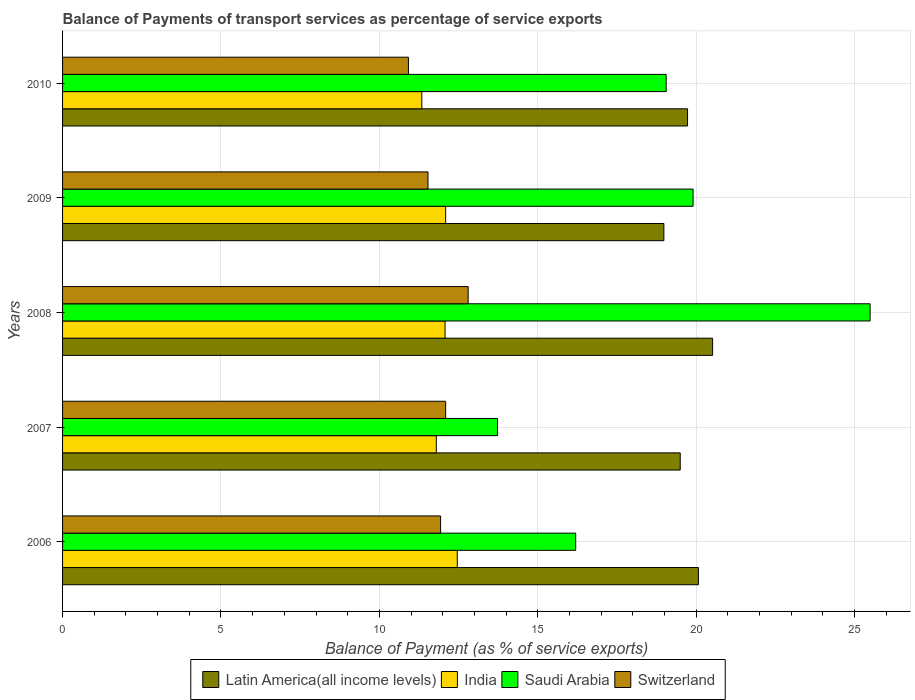How many different coloured bars are there?
Keep it short and to the point. 4. How many groups of bars are there?
Offer a terse response. 5. Are the number of bars per tick equal to the number of legend labels?
Give a very brief answer. Yes. Are the number of bars on each tick of the Y-axis equal?
Your answer should be compact. Yes. How many bars are there on the 3rd tick from the bottom?
Provide a short and direct response. 4. What is the label of the 2nd group of bars from the top?
Offer a very short reply. 2009. What is the balance of payments of transport services in Latin America(all income levels) in 2007?
Provide a short and direct response. 19.5. Across all years, what is the maximum balance of payments of transport services in India?
Your answer should be compact. 12.46. Across all years, what is the minimum balance of payments of transport services in India?
Your answer should be very brief. 11.34. In which year was the balance of payments of transport services in Latin America(all income levels) maximum?
Offer a very short reply. 2008. What is the total balance of payments of transport services in Latin America(all income levels) in the graph?
Your answer should be compact. 98.79. What is the difference between the balance of payments of transport services in Saudi Arabia in 2006 and that in 2010?
Give a very brief answer. -2.86. What is the difference between the balance of payments of transport services in Latin America(all income levels) in 2010 and the balance of payments of transport services in India in 2008?
Your answer should be very brief. 7.65. What is the average balance of payments of transport services in India per year?
Offer a very short reply. 11.95. In the year 2006, what is the difference between the balance of payments of transport services in India and balance of payments of transport services in Saudi Arabia?
Your response must be concise. -3.74. In how many years, is the balance of payments of transport services in Switzerland greater than 18 %?
Your answer should be very brief. 0. What is the ratio of the balance of payments of transport services in Switzerland in 2008 to that in 2009?
Your answer should be very brief. 1.11. Is the difference between the balance of payments of transport services in India in 2006 and 2008 greater than the difference between the balance of payments of transport services in Saudi Arabia in 2006 and 2008?
Your answer should be compact. Yes. What is the difference between the highest and the second highest balance of payments of transport services in India?
Provide a succinct answer. 0.37. What is the difference between the highest and the lowest balance of payments of transport services in Saudi Arabia?
Give a very brief answer. 11.76. Is the sum of the balance of payments of transport services in Switzerland in 2007 and 2008 greater than the maximum balance of payments of transport services in Saudi Arabia across all years?
Your answer should be very brief. No. What does the 1st bar from the top in 2010 represents?
Ensure brevity in your answer.  Switzerland. What does the 4th bar from the bottom in 2009 represents?
Your response must be concise. Switzerland. How many bars are there?
Give a very brief answer. 20. How many years are there in the graph?
Give a very brief answer. 5. Are the values on the major ticks of X-axis written in scientific E-notation?
Give a very brief answer. No. Does the graph contain any zero values?
Offer a very short reply. No. How many legend labels are there?
Give a very brief answer. 4. What is the title of the graph?
Provide a succinct answer. Balance of Payments of transport services as percentage of service exports. Does "Brazil" appear as one of the legend labels in the graph?
Offer a very short reply. No. What is the label or title of the X-axis?
Your answer should be very brief. Balance of Payment (as % of service exports). What is the label or title of the Y-axis?
Your answer should be compact. Years. What is the Balance of Payment (as % of service exports) of Latin America(all income levels) in 2006?
Your answer should be very brief. 20.07. What is the Balance of Payment (as % of service exports) in India in 2006?
Your answer should be very brief. 12.46. What is the Balance of Payment (as % of service exports) of Saudi Arabia in 2006?
Keep it short and to the point. 16.2. What is the Balance of Payment (as % of service exports) in Switzerland in 2006?
Your answer should be compact. 11.93. What is the Balance of Payment (as % of service exports) of Latin America(all income levels) in 2007?
Your answer should be very brief. 19.5. What is the Balance of Payment (as % of service exports) in India in 2007?
Offer a very short reply. 11.8. What is the Balance of Payment (as % of service exports) of Saudi Arabia in 2007?
Give a very brief answer. 13.73. What is the Balance of Payment (as % of service exports) in Switzerland in 2007?
Ensure brevity in your answer.  12.09. What is the Balance of Payment (as % of service exports) of Latin America(all income levels) in 2008?
Offer a terse response. 20.52. What is the Balance of Payment (as % of service exports) of India in 2008?
Your answer should be very brief. 12.07. What is the Balance of Payment (as % of service exports) of Saudi Arabia in 2008?
Offer a very short reply. 25.49. What is the Balance of Payment (as % of service exports) in Switzerland in 2008?
Your answer should be very brief. 12.8. What is the Balance of Payment (as % of service exports) of Latin America(all income levels) in 2009?
Make the answer very short. 18.98. What is the Balance of Payment (as % of service exports) in India in 2009?
Your response must be concise. 12.09. What is the Balance of Payment (as % of service exports) of Saudi Arabia in 2009?
Offer a terse response. 19.9. What is the Balance of Payment (as % of service exports) in Switzerland in 2009?
Ensure brevity in your answer.  11.54. What is the Balance of Payment (as % of service exports) in Latin America(all income levels) in 2010?
Provide a short and direct response. 19.73. What is the Balance of Payment (as % of service exports) of India in 2010?
Ensure brevity in your answer.  11.34. What is the Balance of Payment (as % of service exports) of Saudi Arabia in 2010?
Offer a terse response. 19.05. What is the Balance of Payment (as % of service exports) of Switzerland in 2010?
Provide a short and direct response. 10.92. Across all years, what is the maximum Balance of Payment (as % of service exports) in Latin America(all income levels)?
Keep it short and to the point. 20.52. Across all years, what is the maximum Balance of Payment (as % of service exports) of India?
Your answer should be compact. 12.46. Across all years, what is the maximum Balance of Payment (as % of service exports) in Saudi Arabia?
Make the answer very short. 25.49. Across all years, what is the maximum Balance of Payment (as % of service exports) of Switzerland?
Your response must be concise. 12.8. Across all years, what is the minimum Balance of Payment (as % of service exports) of Latin America(all income levels)?
Give a very brief answer. 18.98. Across all years, what is the minimum Balance of Payment (as % of service exports) of India?
Keep it short and to the point. 11.34. Across all years, what is the minimum Balance of Payment (as % of service exports) of Saudi Arabia?
Keep it short and to the point. 13.73. Across all years, what is the minimum Balance of Payment (as % of service exports) in Switzerland?
Offer a terse response. 10.92. What is the total Balance of Payment (as % of service exports) in Latin America(all income levels) in the graph?
Offer a very short reply. 98.79. What is the total Balance of Payment (as % of service exports) of India in the graph?
Offer a very short reply. 59.76. What is the total Balance of Payment (as % of service exports) of Saudi Arabia in the graph?
Offer a terse response. 94.37. What is the total Balance of Payment (as % of service exports) in Switzerland in the graph?
Provide a short and direct response. 59.28. What is the difference between the Balance of Payment (as % of service exports) of Latin America(all income levels) in 2006 and that in 2007?
Offer a terse response. 0.57. What is the difference between the Balance of Payment (as % of service exports) in India in 2006 and that in 2007?
Provide a succinct answer. 0.66. What is the difference between the Balance of Payment (as % of service exports) of Saudi Arabia in 2006 and that in 2007?
Provide a succinct answer. 2.47. What is the difference between the Balance of Payment (as % of service exports) of Switzerland in 2006 and that in 2007?
Give a very brief answer. -0.16. What is the difference between the Balance of Payment (as % of service exports) of Latin America(all income levels) in 2006 and that in 2008?
Provide a succinct answer. -0.45. What is the difference between the Balance of Payment (as % of service exports) in India in 2006 and that in 2008?
Your answer should be very brief. 0.39. What is the difference between the Balance of Payment (as % of service exports) in Saudi Arabia in 2006 and that in 2008?
Keep it short and to the point. -9.29. What is the difference between the Balance of Payment (as % of service exports) of Switzerland in 2006 and that in 2008?
Ensure brevity in your answer.  -0.87. What is the difference between the Balance of Payment (as % of service exports) of Latin America(all income levels) in 2006 and that in 2009?
Ensure brevity in your answer.  1.09. What is the difference between the Balance of Payment (as % of service exports) in India in 2006 and that in 2009?
Your answer should be compact. 0.37. What is the difference between the Balance of Payment (as % of service exports) in Saudi Arabia in 2006 and that in 2009?
Your answer should be very brief. -3.71. What is the difference between the Balance of Payment (as % of service exports) of Switzerland in 2006 and that in 2009?
Your response must be concise. 0.4. What is the difference between the Balance of Payment (as % of service exports) in Latin America(all income levels) in 2006 and that in 2010?
Keep it short and to the point. 0.34. What is the difference between the Balance of Payment (as % of service exports) of India in 2006 and that in 2010?
Your response must be concise. 1.12. What is the difference between the Balance of Payment (as % of service exports) in Saudi Arabia in 2006 and that in 2010?
Make the answer very short. -2.86. What is the difference between the Balance of Payment (as % of service exports) in Switzerland in 2006 and that in 2010?
Offer a terse response. 1.01. What is the difference between the Balance of Payment (as % of service exports) in Latin America(all income levels) in 2007 and that in 2008?
Your answer should be very brief. -1.02. What is the difference between the Balance of Payment (as % of service exports) of India in 2007 and that in 2008?
Provide a succinct answer. -0.28. What is the difference between the Balance of Payment (as % of service exports) in Saudi Arabia in 2007 and that in 2008?
Offer a terse response. -11.76. What is the difference between the Balance of Payment (as % of service exports) in Switzerland in 2007 and that in 2008?
Provide a short and direct response. -0.71. What is the difference between the Balance of Payment (as % of service exports) in Latin America(all income levels) in 2007 and that in 2009?
Offer a terse response. 0.52. What is the difference between the Balance of Payment (as % of service exports) of India in 2007 and that in 2009?
Provide a short and direct response. -0.3. What is the difference between the Balance of Payment (as % of service exports) in Saudi Arabia in 2007 and that in 2009?
Your answer should be compact. -6.17. What is the difference between the Balance of Payment (as % of service exports) of Switzerland in 2007 and that in 2009?
Your answer should be very brief. 0.56. What is the difference between the Balance of Payment (as % of service exports) in Latin America(all income levels) in 2007 and that in 2010?
Offer a very short reply. -0.23. What is the difference between the Balance of Payment (as % of service exports) of India in 2007 and that in 2010?
Ensure brevity in your answer.  0.46. What is the difference between the Balance of Payment (as % of service exports) in Saudi Arabia in 2007 and that in 2010?
Give a very brief answer. -5.33. What is the difference between the Balance of Payment (as % of service exports) of Switzerland in 2007 and that in 2010?
Keep it short and to the point. 1.17. What is the difference between the Balance of Payment (as % of service exports) in Latin America(all income levels) in 2008 and that in 2009?
Your response must be concise. 1.54. What is the difference between the Balance of Payment (as % of service exports) in India in 2008 and that in 2009?
Keep it short and to the point. -0.02. What is the difference between the Balance of Payment (as % of service exports) in Saudi Arabia in 2008 and that in 2009?
Provide a succinct answer. 5.59. What is the difference between the Balance of Payment (as % of service exports) of Switzerland in 2008 and that in 2009?
Make the answer very short. 1.27. What is the difference between the Balance of Payment (as % of service exports) in Latin America(all income levels) in 2008 and that in 2010?
Your response must be concise. 0.79. What is the difference between the Balance of Payment (as % of service exports) in India in 2008 and that in 2010?
Keep it short and to the point. 0.73. What is the difference between the Balance of Payment (as % of service exports) in Saudi Arabia in 2008 and that in 2010?
Offer a very short reply. 6.44. What is the difference between the Balance of Payment (as % of service exports) of Switzerland in 2008 and that in 2010?
Make the answer very short. 1.89. What is the difference between the Balance of Payment (as % of service exports) in Latin America(all income levels) in 2009 and that in 2010?
Provide a short and direct response. -0.75. What is the difference between the Balance of Payment (as % of service exports) of India in 2009 and that in 2010?
Provide a short and direct response. 0.75. What is the difference between the Balance of Payment (as % of service exports) in Saudi Arabia in 2009 and that in 2010?
Provide a succinct answer. 0.85. What is the difference between the Balance of Payment (as % of service exports) of Switzerland in 2009 and that in 2010?
Give a very brief answer. 0.62. What is the difference between the Balance of Payment (as % of service exports) of Latin America(all income levels) in 2006 and the Balance of Payment (as % of service exports) of India in 2007?
Ensure brevity in your answer.  8.27. What is the difference between the Balance of Payment (as % of service exports) in Latin America(all income levels) in 2006 and the Balance of Payment (as % of service exports) in Saudi Arabia in 2007?
Ensure brevity in your answer.  6.34. What is the difference between the Balance of Payment (as % of service exports) of Latin America(all income levels) in 2006 and the Balance of Payment (as % of service exports) of Switzerland in 2007?
Give a very brief answer. 7.98. What is the difference between the Balance of Payment (as % of service exports) of India in 2006 and the Balance of Payment (as % of service exports) of Saudi Arabia in 2007?
Make the answer very short. -1.27. What is the difference between the Balance of Payment (as % of service exports) of India in 2006 and the Balance of Payment (as % of service exports) of Switzerland in 2007?
Provide a succinct answer. 0.37. What is the difference between the Balance of Payment (as % of service exports) in Saudi Arabia in 2006 and the Balance of Payment (as % of service exports) in Switzerland in 2007?
Your response must be concise. 4.1. What is the difference between the Balance of Payment (as % of service exports) of Latin America(all income levels) in 2006 and the Balance of Payment (as % of service exports) of India in 2008?
Keep it short and to the point. 8. What is the difference between the Balance of Payment (as % of service exports) in Latin America(all income levels) in 2006 and the Balance of Payment (as % of service exports) in Saudi Arabia in 2008?
Your answer should be compact. -5.42. What is the difference between the Balance of Payment (as % of service exports) in Latin America(all income levels) in 2006 and the Balance of Payment (as % of service exports) in Switzerland in 2008?
Provide a succinct answer. 7.27. What is the difference between the Balance of Payment (as % of service exports) in India in 2006 and the Balance of Payment (as % of service exports) in Saudi Arabia in 2008?
Give a very brief answer. -13.03. What is the difference between the Balance of Payment (as % of service exports) of India in 2006 and the Balance of Payment (as % of service exports) of Switzerland in 2008?
Your answer should be very brief. -0.34. What is the difference between the Balance of Payment (as % of service exports) in Saudi Arabia in 2006 and the Balance of Payment (as % of service exports) in Switzerland in 2008?
Your response must be concise. 3.39. What is the difference between the Balance of Payment (as % of service exports) in Latin America(all income levels) in 2006 and the Balance of Payment (as % of service exports) in India in 2009?
Offer a very short reply. 7.98. What is the difference between the Balance of Payment (as % of service exports) of Latin America(all income levels) in 2006 and the Balance of Payment (as % of service exports) of Saudi Arabia in 2009?
Ensure brevity in your answer.  0.17. What is the difference between the Balance of Payment (as % of service exports) in Latin America(all income levels) in 2006 and the Balance of Payment (as % of service exports) in Switzerland in 2009?
Keep it short and to the point. 8.54. What is the difference between the Balance of Payment (as % of service exports) in India in 2006 and the Balance of Payment (as % of service exports) in Saudi Arabia in 2009?
Keep it short and to the point. -7.44. What is the difference between the Balance of Payment (as % of service exports) of India in 2006 and the Balance of Payment (as % of service exports) of Switzerland in 2009?
Your answer should be compact. 0.92. What is the difference between the Balance of Payment (as % of service exports) in Saudi Arabia in 2006 and the Balance of Payment (as % of service exports) in Switzerland in 2009?
Make the answer very short. 4.66. What is the difference between the Balance of Payment (as % of service exports) of Latin America(all income levels) in 2006 and the Balance of Payment (as % of service exports) of India in 2010?
Your response must be concise. 8.73. What is the difference between the Balance of Payment (as % of service exports) of Latin America(all income levels) in 2006 and the Balance of Payment (as % of service exports) of Saudi Arabia in 2010?
Make the answer very short. 1.02. What is the difference between the Balance of Payment (as % of service exports) in Latin America(all income levels) in 2006 and the Balance of Payment (as % of service exports) in Switzerland in 2010?
Ensure brevity in your answer.  9.15. What is the difference between the Balance of Payment (as % of service exports) in India in 2006 and the Balance of Payment (as % of service exports) in Saudi Arabia in 2010?
Offer a very short reply. -6.59. What is the difference between the Balance of Payment (as % of service exports) of India in 2006 and the Balance of Payment (as % of service exports) of Switzerland in 2010?
Provide a short and direct response. 1.54. What is the difference between the Balance of Payment (as % of service exports) in Saudi Arabia in 2006 and the Balance of Payment (as % of service exports) in Switzerland in 2010?
Make the answer very short. 5.28. What is the difference between the Balance of Payment (as % of service exports) in Latin America(all income levels) in 2007 and the Balance of Payment (as % of service exports) in India in 2008?
Keep it short and to the point. 7.42. What is the difference between the Balance of Payment (as % of service exports) of Latin America(all income levels) in 2007 and the Balance of Payment (as % of service exports) of Saudi Arabia in 2008?
Give a very brief answer. -5.99. What is the difference between the Balance of Payment (as % of service exports) in Latin America(all income levels) in 2007 and the Balance of Payment (as % of service exports) in Switzerland in 2008?
Ensure brevity in your answer.  6.69. What is the difference between the Balance of Payment (as % of service exports) of India in 2007 and the Balance of Payment (as % of service exports) of Saudi Arabia in 2008?
Give a very brief answer. -13.69. What is the difference between the Balance of Payment (as % of service exports) of India in 2007 and the Balance of Payment (as % of service exports) of Switzerland in 2008?
Offer a very short reply. -1.01. What is the difference between the Balance of Payment (as % of service exports) of Saudi Arabia in 2007 and the Balance of Payment (as % of service exports) of Switzerland in 2008?
Give a very brief answer. 0.93. What is the difference between the Balance of Payment (as % of service exports) of Latin America(all income levels) in 2007 and the Balance of Payment (as % of service exports) of India in 2009?
Give a very brief answer. 7.4. What is the difference between the Balance of Payment (as % of service exports) of Latin America(all income levels) in 2007 and the Balance of Payment (as % of service exports) of Saudi Arabia in 2009?
Your answer should be compact. -0.41. What is the difference between the Balance of Payment (as % of service exports) in Latin America(all income levels) in 2007 and the Balance of Payment (as % of service exports) in Switzerland in 2009?
Your answer should be compact. 7.96. What is the difference between the Balance of Payment (as % of service exports) in India in 2007 and the Balance of Payment (as % of service exports) in Saudi Arabia in 2009?
Offer a very short reply. -8.11. What is the difference between the Balance of Payment (as % of service exports) in India in 2007 and the Balance of Payment (as % of service exports) in Switzerland in 2009?
Provide a succinct answer. 0.26. What is the difference between the Balance of Payment (as % of service exports) of Saudi Arabia in 2007 and the Balance of Payment (as % of service exports) of Switzerland in 2009?
Your answer should be very brief. 2.19. What is the difference between the Balance of Payment (as % of service exports) of Latin America(all income levels) in 2007 and the Balance of Payment (as % of service exports) of India in 2010?
Ensure brevity in your answer.  8.16. What is the difference between the Balance of Payment (as % of service exports) of Latin America(all income levels) in 2007 and the Balance of Payment (as % of service exports) of Saudi Arabia in 2010?
Provide a short and direct response. 0.44. What is the difference between the Balance of Payment (as % of service exports) in Latin America(all income levels) in 2007 and the Balance of Payment (as % of service exports) in Switzerland in 2010?
Offer a very short reply. 8.58. What is the difference between the Balance of Payment (as % of service exports) in India in 2007 and the Balance of Payment (as % of service exports) in Saudi Arabia in 2010?
Offer a terse response. -7.26. What is the difference between the Balance of Payment (as % of service exports) in India in 2007 and the Balance of Payment (as % of service exports) in Switzerland in 2010?
Keep it short and to the point. 0.88. What is the difference between the Balance of Payment (as % of service exports) of Saudi Arabia in 2007 and the Balance of Payment (as % of service exports) of Switzerland in 2010?
Your answer should be compact. 2.81. What is the difference between the Balance of Payment (as % of service exports) in Latin America(all income levels) in 2008 and the Balance of Payment (as % of service exports) in India in 2009?
Offer a terse response. 8.43. What is the difference between the Balance of Payment (as % of service exports) of Latin America(all income levels) in 2008 and the Balance of Payment (as % of service exports) of Saudi Arabia in 2009?
Your response must be concise. 0.62. What is the difference between the Balance of Payment (as % of service exports) of Latin America(all income levels) in 2008 and the Balance of Payment (as % of service exports) of Switzerland in 2009?
Offer a very short reply. 8.98. What is the difference between the Balance of Payment (as % of service exports) in India in 2008 and the Balance of Payment (as % of service exports) in Saudi Arabia in 2009?
Ensure brevity in your answer.  -7.83. What is the difference between the Balance of Payment (as % of service exports) in India in 2008 and the Balance of Payment (as % of service exports) in Switzerland in 2009?
Give a very brief answer. 0.54. What is the difference between the Balance of Payment (as % of service exports) of Saudi Arabia in 2008 and the Balance of Payment (as % of service exports) of Switzerland in 2009?
Ensure brevity in your answer.  13.96. What is the difference between the Balance of Payment (as % of service exports) of Latin America(all income levels) in 2008 and the Balance of Payment (as % of service exports) of India in 2010?
Provide a short and direct response. 9.18. What is the difference between the Balance of Payment (as % of service exports) in Latin America(all income levels) in 2008 and the Balance of Payment (as % of service exports) in Saudi Arabia in 2010?
Ensure brevity in your answer.  1.47. What is the difference between the Balance of Payment (as % of service exports) in Latin America(all income levels) in 2008 and the Balance of Payment (as % of service exports) in Switzerland in 2010?
Your answer should be compact. 9.6. What is the difference between the Balance of Payment (as % of service exports) of India in 2008 and the Balance of Payment (as % of service exports) of Saudi Arabia in 2010?
Offer a very short reply. -6.98. What is the difference between the Balance of Payment (as % of service exports) of India in 2008 and the Balance of Payment (as % of service exports) of Switzerland in 2010?
Keep it short and to the point. 1.16. What is the difference between the Balance of Payment (as % of service exports) of Saudi Arabia in 2008 and the Balance of Payment (as % of service exports) of Switzerland in 2010?
Ensure brevity in your answer.  14.57. What is the difference between the Balance of Payment (as % of service exports) of Latin America(all income levels) in 2009 and the Balance of Payment (as % of service exports) of India in 2010?
Offer a very short reply. 7.64. What is the difference between the Balance of Payment (as % of service exports) in Latin America(all income levels) in 2009 and the Balance of Payment (as % of service exports) in Saudi Arabia in 2010?
Your answer should be compact. -0.07. What is the difference between the Balance of Payment (as % of service exports) of Latin America(all income levels) in 2009 and the Balance of Payment (as % of service exports) of Switzerland in 2010?
Provide a short and direct response. 8.06. What is the difference between the Balance of Payment (as % of service exports) in India in 2009 and the Balance of Payment (as % of service exports) in Saudi Arabia in 2010?
Offer a very short reply. -6.96. What is the difference between the Balance of Payment (as % of service exports) in India in 2009 and the Balance of Payment (as % of service exports) in Switzerland in 2010?
Ensure brevity in your answer.  1.18. What is the difference between the Balance of Payment (as % of service exports) of Saudi Arabia in 2009 and the Balance of Payment (as % of service exports) of Switzerland in 2010?
Provide a short and direct response. 8.98. What is the average Balance of Payment (as % of service exports) in Latin America(all income levels) per year?
Give a very brief answer. 19.76. What is the average Balance of Payment (as % of service exports) of India per year?
Your response must be concise. 11.95. What is the average Balance of Payment (as % of service exports) in Saudi Arabia per year?
Offer a terse response. 18.87. What is the average Balance of Payment (as % of service exports) of Switzerland per year?
Provide a short and direct response. 11.86. In the year 2006, what is the difference between the Balance of Payment (as % of service exports) of Latin America(all income levels) and Balance of Payment (as % of service exports) of India?
Give a very brief answer. 7.61. In the year 2006, what is the difference between the Balance of Payment (as % of service exports) of Latin America(all income levels) and Balance of Payment (as % of service exports) of Saudi Arabia?
Make the answer very short. 3.87. In the year 2006, what is the difference between the Balance of Payment (as % of service exports) in Latin America(all income levels) and Balance of Payment (as % of service exports) in Switzerland?
Provide a succinct answer. 8.14. In the year 2006, what is the difference between the Balance of Payment (as % of service exports) of India and Balance of Payment (as % of service exports) of Saudi Arabia?
Give a very brief answer. -3.74. In the year 2006, what is the difference between the Balance of Payment (as % of service exports) of India and Balance of Payment (as % of service exports) of Switzerland?
Make the answer very short. 0.53. In the year 2006, what is the difference between the Balance of Payment (as % of service exports) in Saudi Arabia and Balance of Payment (as % of service exports) in Switzerland?
Offer a terse response. 4.26. In the year 2007, what is the difference between the Balance of Payment (as % of service exports) in Latin America(all income levels) and Balance of Payment (as % of service exports) in India?
Make the answer very short. 7.7. In the year 2007, what is the difference between the Balance of Payment (as % of service exports) of Latin America(all income levels) and Balance of Payment (as % of service exports) of Saudi Arabia?
Offer a terse response. 5.77. In the year 2007, what is the difference between the Balance of Payment (as % of service exports) of Latin America(all income levels) and Balance of Payment (as % of service exports) of Switzerland?
Offer a terse response. 7.4. In the year 2007, what is the difference between the Balance of Payment (as % of service exports) of India and Balance of Payment (as % of service exports) of Saudi Arabia?
Offer a very short reply. -1.93. In the year 2007, what is the difference between the Balance of Payment (as % of service exports) in India and Balance of Payment (as % of service exports) in Switzerland?
Offer a terse response. -0.29. In the year 2007, what is the difference between the Balance of Payment (as % of service exports) of Saudi Arabia and Balance of Payment (as % of service exports) of Switzerland?
Provide a short and direct response. 1.64. In the year 2008, what is the difference between the Balance of Payment (as % of service exports) of Latin America(all income levels) and Balance of Payment (as % of service exports) of India?
Your answer should be compact. 8.45. In the year 2008, what is the difference between the Balance of Payment (as % of service exports) in Latin America(all income levels) and Balance of Payment (as % of service exports) in Saudi Arabia?
Provide a succinct answer. -4.97. In the year 2008, what is the difference between the Balance of Payment (as % of service exports) of Latin America(all income levels) and Balance of Payment (as % of service exports) of Switzerland?
Keep it short and to the point. 7.72. In the year 2008, what is the difference between the Balance of Payment (as % of service exports) in India and Balance of Payment (as % of service exports) in Saudi Arabia?
Offer a very short reply. -13.42. In the year 2008, what is the difference between the Balance of Payment (as % of service exports) of India and Balance of Payment (as % of service exports) of Switzerland?
Make the answer very short. -0.73. In the year 2008, what is the difference between the Balance of Payment (as % of service exports) of Saudi Arabia and Balance of Payment (as % of service exports) of Switzerland?
Offer a very short reply. 12.69. In the year 2009, what is the difference between the Balance of Payment (as % of service exports) in Latin America(all income levels) and Balance of Payment (as % of service exports) in India?
Keep it short and to the point. 6.89. In the year 2009, what is the difference between the Balance of Payment (as % of service exports) in Latin America(all income levels) and Balance of Payment (as % of service exports) in Saudi Arabia?
Give a very brief answer. -0.92. In the year 2009, what is the difference between the Balance of Payment (as % of service exports) in Latin America(all income levels) and Balance of Payment (as % of service exports) in Switzerland?
Provide a short and direct response. 7.45. In the year 2009, what is the difference between the Balance of Payment (as % of service exports) of India and Balance of Payment (as % of service exports) of Saudi Arabia?
Your answer should be compact. -7.81. In the year 2009, what is the difference between the Balance of Payment (as % of service exports) in India and Balance of Payment (as % of service exports) in Switzerland?
Your answer should be very brief. 0.56. In the year 2009, what is the difference between the Balance of Payment (as % of service exports) of Saudi Arabia and Balance of Payment (as % of service exports) of Switzerland?
Your answer should be very brief. 8.37. In the year 2010, what is the difference between the Balance of Payment (as % of service exports) of Latin America(all income levels) and Balance of Payment (as % of service exports) of India?
Keep it short and to the point. 8.39. In the year 2010, what is the difference between the Balance of Payment (as % of service exports) of Latin America(all income levels) and Balance of Payment (as % of service exports) of Saudi Arabia?
Offer a very short reply. 0.67. In the year 2010, what is the difference between the Balance of Payment (as % of service exports) of Latin America(all income levels) and Balance of Payment (as % of service exports) of Switzerland?
Your answer should be very brief. 8.81. In the year 2010, what is the difference between the Balance of Payment (as % of service exports) of India and Balance of Payment (as % of service exports) of Saudi Arabia?
Give a very brief answer. -7.71. In the year 2010, what is the difference between the Balance of Payment (as % of service exports) of India and Balance of Payment (as % of service exports) of Switzerland?
Offer a terse response. 0.42. In the year 2010, what is the difference between the Balance of Payment (as % of service exports) of Saudi Arabia and Balance of Payment (as % of service exports) of Switzerland?
Your answer should be very brief. 8.14. What is the ratio of the Balance of Payment (as % of service exports) in Latin America(all income levels) in 2006 to that in 2007?
Provide a succinct answer. 1.03. What is the ratio of the Balance of Payment (as % of service exports) in India in 2006 to that in 2007?
Offer a terse response. 1.06. What is the ratio of the Balance of Payment (as % of service exports) in Saudi Arabia in 2006 to that in 2007?
Make the answer very short. 1.18. What is the ratio of the Balance of Payment (as % of service exports) of Latin America(all income levels) in 2006 to that in 2008?
Offer a very short reply. 0.98. What is the ratio of the Balance of Payment (as % of service exports) in India in 2006 to that in 2008?
Your answer should be very brief. 1.03. What is the ratio of the Balance of Payment (as % of service exports) in Saudi Arabia in 2006 to that in 2008?
Make the answer very short. 0.64. What is the ratio of the Balance of Payment (as % of service exports) in Switzerland in 2006 to that in 2008?
Ensure brevity in your answer.  0.93. What is the ratio of the Balance of Payment (as % of service exports) in Latin America(all income levels) in 2006 to that in 2009?
Make the answer very short. 1.06. What is the ratio of the Balance of Payment (as % of service exports) in India in 2006 to that in 2009?
Provide a short and direct response. 1.03. What is the ratio of the Balance of Payment (as % of service exports) of Saudi Arabia in 2006 to that in 2009?
Ensure brevity in your answer.  0.81. What is the ratio of the Balance of Payment (as % of service exports) in Switzerland in 2006 to that in 2009?
Offer a terse response. 1.03. What is the ratio of the Balance of Payment (as % of service exports) in Latin America(all income levels) in 2006 to that in 2010?
Provide a succinct answer. 1.02. What is the ratio of the Balance of Payment (as % of service exports) in India in 2006 to that in 2010?
Your response must be concise. 1.1. What is the ratio of the Balance of Payment (as % of service exports) of Saudi Arabia in 2006 to that in 2010?
Your answer should be very brief. 0.85. What is the ratio of the Balance of Payment (as % of service exports) of Switzerland in 2006 to that in 2010?
Offer a terse response. 1.09. What is the ratio of the Balance of Payment (as % of service exports) in Latin America(all income levels) in 2007 to that in 2008?
Ensure brevity in your answer.  0.95. What is the ratio of the Balance of Payment (as % of service exports) in India in 2007 to that in 2008?
Your answer should be very brief. 0.98. What is the ratio of the Balance of Payment (as % of service exports) of Saudi Arabia in 2007 to that in 2008?
Your answer should be compact. 0.54. What is the ratio of the Balance of Payment (as % of service exports) in Switzerland in 2007 to that in 2008?
Give a very brief answer. 0.94. What is the ratio of the Balance of Payment (as % of service exports) of Latin America(all income levels) in 2007 to that in 2009?
Offer a terse response. 1.03. What is the ratio of the Balance of Payment (as % of service exports) of India in 2007 to that in 2009?
Offer a very short reply. 0.98. What is the ratio of the Balance of Payment (as % of service exports) in Saudi Arabia in 2007 to that in 2009?
Provide a short and direct response. 0.69. What is the ratio of the Balance of Payment (as % of service exports) in Switzerland in 2007 to that in 2009?
Give a very brief answer. 1.05. What is the ratio of the Balance of Payment (as % of service exports) in Latin America(all income levels) in 2007 to that in 2010?
Offer a very short reply. 0.99. What is the ratio of the Balance of Payment (as % of service exports) in India in 2007 to that in 2010?
Offer a very short reply. 1.04. What is the ratio of the Balance of Payment (as % of service exports) in Saudi Arabia in 2007 to that in 2010?
Offer a very short reply. 0.72. What is the ratio of the Balance of Payment (as % of service exports) in Switzerland in 2007 to that in 2010?
Provide a succinct answer. 1.11. What is the ratio of the Balance of Payment (as % of service exports) in Latin America(all income levels) in 2008 to that in 2009?
Offer a very short reply. 1.08. What is the ratio of the Balance of Payment (as % of service exports) of Saudi Arabia in 2008 to that in 2009?
Your answer should be very brief. 1.28. What is the ratio of the Balance of Payment (as % of service exports) of Switzerland in 2008 to that in 2009?
Your response must be concise. 1.11. What is the ratio of the Balance of Payment (as % of service exports) of Latin America(all income levels) in 2008 to that in 2010?
Provide a succinct answer. 1.04. What is the ratio of the Balance of Payment (as % of service exports) of India in 2008 to that in 2010?
Ensure brevity in your answer.  1.06. What is the ratio of the Balance of Payment (as % of service exports) of Saudi Arabia in 2008 to that in 2010?
Your answer should be compact. 1.34. What is the ratio of the Balance of Payment (as % of service exports) in Switzerland in 2008 to that in 2010?
Give a very brief answer. 1.17. What is the ratio of the Balance of Payment (as % of service exports) of Latin America(all income levels) in 2009 to that in 2010?
Your answer should be very brief. 0.96. What is the ratio of the Balance of Payment (as % of service exports) of India in 2009 to that in 2010?
Your response must be concise. 1.07. What is the ratio of the Balance of Payment (as % of service exports) of Saudi Arabia in 2009 to that in 2010?
Ensure brevity in your answer.  1.04. What is the ratio of the Balance of Payment (as % of service exports) in Switzerland in 2009 to that in 2010?
Make the answer very short. 1.06. What is the difference between the highest and the second highest Balance of Payment (as % of service exports) in Latin America(all income levels)?
Your response must be concise. 0.45. What is the difference between the highest and the second highest Balance of Payment (as % of service exports) in India?
Give a very brief answer. 0.37. What is the difference between the highest and the second highest Balance of Payment (as % of service exports) of Saudi Arabia?
Offer a very short reply. 5.59. What is the difference between the highest and the second highest Balance of Payment (as % of service exports) of Switzerland?
Give a very brief answer. 0.71. What is the difference between the highest and the lowest Balance of Payment (as % of service exports) in Latin America(all income levels)?
Ensure brevity in your answer.  1.54. What is the difference between the highest and the lowest Balance of Payment (as % of service exports) in India?
Ensure brevity in your answer.  1.12. What is the difference between the highest and the lowest Balance of Payment (as % of service exports) in Saudi Arabia?
Ensure brevity in your answer.  11.76. What is the difference between the highest and the lowest Balance of Payment (as % of service exports) in Switzerland?
Your response must be concise. 1.89. 